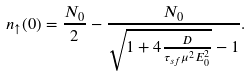Convert formula to latex. <formula><loc_0><loc_0><loc_500><loc_500>n _ { \uparrow } ( 0 ) = \frac { N _ { 0 } } { 2 } - \frac { N _ { 0 } } { \sqrt { 1 + 4 \frac { D } { \tau _ { s f } \mu ^ { 2 } E _ { 0 } ^ { 2 } } } - 1 } .</formula> 